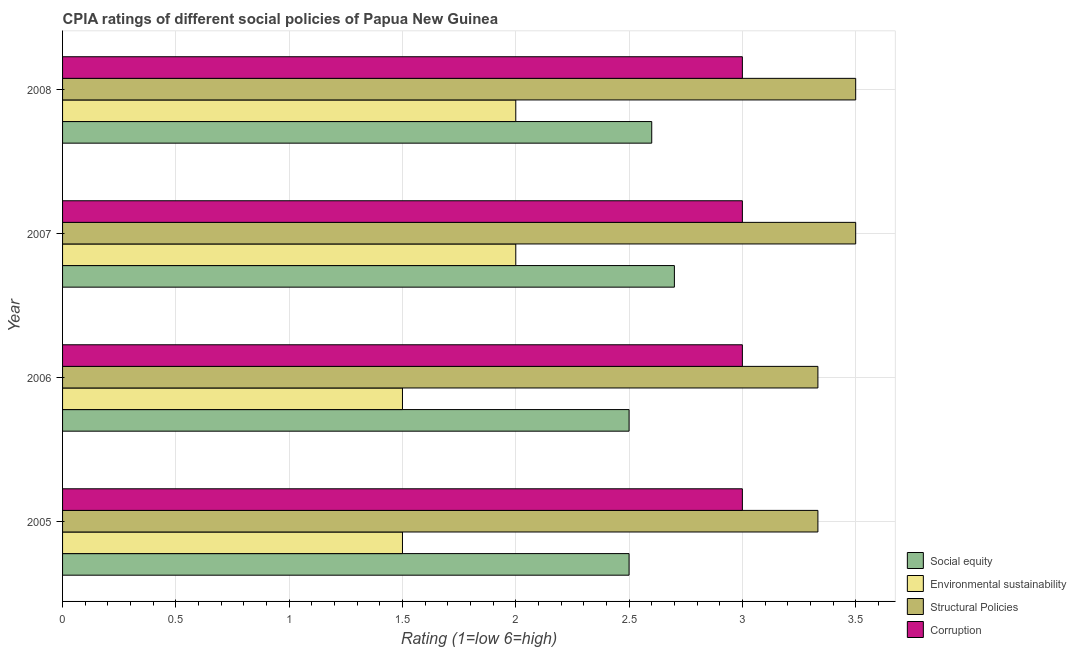How many groups of bars are there?
Provide a succinct answer. 4. Are the number of bars on each tick of the Y-axis equal?
Make the answer very short. Yes. How many bars are there on the 3rd tick from the top?
Give a very brief answer. 4. How many bars are there on the 4th tick from the bottom?
Your answer should be compact. 4. In how many cases, is the number of bars for a given year not equal to the number of legend labels?
Offer a very short reply. 0. What is the cpia rating of corruption in 2007?
Provide a short and direct response. 3. Across all years, what is the minimum cpia rating of environmental sustainability?
Your response must be concise. 1.5. In which year was the cpia rating of social equity maximum?
Your answer should be compact. 2007. In which year was the cpia rating of environmental sustainability minimum?
Offer a very short reply. 2005. What is the total cpia rating of corruption in the graph?
Your answer should be compact. 12. What is the difference between the cpia rating of environmental sustainability in 2007 and the cpia rating of structural policies in 2008?
Provide a short and direct response. -1.5. In the year 2006, what is the difference between the cpia rating of structural policies and cpia rating of corruption?
Provide a short and direct response. 0.33. In how many years, is the cpia rating of environmental sustainability greater than 2.7 ?
Make the answer very short. 0. What is the difference between the highest and the second highest cpia rating of environmental sustainability?
Provide a succinct answer. 0. What is the difference between the highest and the lowest cpia rating of environmental sustainability?
Ensure brevity in your answer.  0.5. In how many years, is the cpia rating of corruption greater than the average cpia rating of corruption taken over all years?
Provide a short and direct response. 0. What does the 1st bar from the top in 2008 represents?
Your response must be concise. Corruption. What does the 3rd bar from the bottom in 2005 represents?
Your answer should be compact. Structural Policies. How many bars are there?
Keep it short and to the point. 16. Are all the bars in the graph horizontal?
Provide a short and direct response. Yes. Are the values on the major ticks of X-axis written in scientific E-notation?
Offer a very short reply. No. Does the graph contain any zero values?
Make the answer very short. No. Does the graph contain grids?
Keep it short and to the point. Yes. Where does the legend appear in the graph?
Ensure brevity in your answer.  Bottom right. How many legend labels are there?
Give a very brief answer. 4. What is the title of the graph?
Provide a short and direct response. CPIA ratings of different social policies of Papua New Guinea. What is the label or title of the X-axis?
Your answer should be compact. Rating (1=low 6=high). What is the Rating (1=low 6=high) in Environmental sustainability in 2005?
Keep it short and to the point. 1.5. What is the Rating (1=low 6=high) of Structural Policies in 2005?
Make the answer very short. 3.33. What is the Rating (1=low 6=high) of Corruption in 2005?
Give a very brief answer. 3. What is the Rating (1=low 6=high) of Social equity in 2006?
Your response must be concise. 2.5. What is the Rating (1=low 6=high) of Structural Policies in 2006?
Provide a succinct answer. 3.33. What is the Rating (1=low 6=high) in Corruption in 2006?
Keep it short and to the point. 3. What is the Rating (1=low 6=high) in Social equity in 2007?
Give a very brief answer. 2.7. What is the Rating (1=low 6=high) of Structural Policies in 2007?
Provide a short and direct response. 3.5. What is the Rating (1=low 6=high) in Corruption in 2007?
Provide a short and direct response. 3. What is the Rating (1=low 6=high) in Structural Policies in 2008?
Ensure brevity in your answer.  3.5. Across all years, what is the maximum Rating (1=low 6=high) of Structural Policies?
Provide a succinct answer. 3.5. Across all years, what is the minimum Rating (1=low 6=high) of Environmental sustainability?
Ensure brevity in your answer.  1.5. Across all years, what is the minimum Rating (1=low 6=high) of Structural Policies?
Your response must be concise. 3.33. What is the total Rating (1=low 6=high) in Social equity in the graph?
Your answer should be compact. 10.3. What is the total Rating (1=low 6=high) of Structural Policies in the graph?
Make the answer very short. 13.67. What is the total Rating (1=low 6=high) in Corruption in the graph?
Ensure brevity in your answer.  12. What is the difference between the Rating (1=low 6=high) of Environmental sustainability in 2005 and that in 2006?
Provide a short and direct response. 0. What is the difference between the Rating (1=low 6=high) in Corruption in 2005 and that in 2006?
Keep it short and to the point. 0. What is the difference between the Rating (1=low 6=high) in Social equity in 2005 and that in 2007?
Your response must be concise. -0.2. What is the difference between the Rating (1=low 6=high) in Corruption in 2005 and that in 2007?
Make the answer very short. 0. What is the difference between the Rating (1=low 6=high) of Social equity in 2005 and that in 2008?
Offer a terse response. -0.1. What is the difference between the Rating (1=low 6=high) of Environmental sustainability in 2005 and that in 2008?
Your answer should be compact. -0.5. What is the difference between the Rating (1=low 6=high) of Structural Policies in 2005 and that in 2008?
Give a very brief answer. -0.17. What is the difference between the Rating (1=low 6=high) of Corruption in 2005 and that in 2008?
Offer a terse response. 0. What is the difference between the Rating (1=low 6=high) of Social equity in 2006 and that in 2007?
Give a very brief answer. -0.2. What is the difference between the Rating (1=low 6=high) of Environmental sustainability in 2006 and that in 2007?
Offer a terse response. -0.5. What is the difference between the Rating (1=low 6=high) in Structural Policies in 2006 and that in 2007?
Offer a terse response. -0.17. What is the difference between the Rating (1=low 6=high) in Corruption in 2006 and that in 2007?
Provide a short and direct response. 0. What is the difference between the Rating (1=low 6=high) of Social equity in 2006 and that in 2008?
Provide a short and direct response. -0.1. What is the difference between the Rating (1=low 6=high) of Structural Policies in 2006 and that in 2008?
Offer a terse response. -0.17. What is the difference between the Rating (1=low 6=high) of Corruption in 2006 and that in 2008?
Ensure brevity in your answer.  0. What is the difference between the Rating (1=low 6=high) of Social equity in 2007 and that in 2008?
Offer a terse response. 0.1. What is the difference between the Rating (1=low 6=high) of Structural Policies in 2007 and that in 2008?
Keep it short and to the point. 0. What is the difference between the Rating (1=low 6=high) in Corruption in 2007 and that in 2008?
Keep it short and to the point. 0. What is the difference between the Rating (1=low 6=high) in Social equity in 2005 and the Rating (1=low 6=high) in Environmental sustainability in 2006?
Provide a short and direct response. 1. What is the difference between the Rating (1=low 6=high) in Social equity in 2005 and the Rating (1=low 6=high) in Corruption in 2006?
Offer a terse response. -0.5. What is the difference between the Rating (1=low 6=high) of Environmental sustainability in 2005 and the Rating (1=low 6=high) of Structural Policies in 2006?
Ensure brevity in your answer.  -1.83. What is the difference between the Rating (1=low 6=high) of Social equity in 2005 and the Rating (1=low 6=high) of Corruption in 2007?
Offer a very short reply. -0.5. What is the difference between the Rating (1=low 6=high) in Environmental sustainability in 2005 and the Rating (1=low 6=high) in Corruption in 2007?
Ensure brevity in your answer.  -1.5. What is the difference between the Rating (1=low 6=high) in Social equity in 2005 and the Rating (1=low 6=high) in Environmental sustainability in 2008?
Provide a succinct answer. 0.5. What is the difference between the Rating (1=low 6=high) in Social equity in 2005 and the Rating (1=low 6=high) in Corruption in 2008?
Provide a succinct answer. -0.5. What is the difference between the Rating (1=low 6=high) in Structural Policies in 2005 and the Rating (1=low 6=high) in Corruption in 2008?
Offer a terse response. 0.33. What is the difference between the Rating (1=low 6=high) of Social equity in 2006 and the Rating (1=low 6=high) of Environmental sustainability in 2007?
Your answer should be compact. 0.5. What is the difference between the Rating (1=low 6=high) of Social equity in 2006 and the Rating (1=low 6=high) of Corruption in 2007?
Give a very brief answer. -0.5. What is the difference between the Rating (1=low 6=high) of Environmental sustainability in 2006 and the Rating (1=low 6=high) of Corruption in 2007?
Your response must be concise. -1.5. What is the difference between the Rating (1=low 6=high) in Social equity in 2006 and the Rating (1=low 6=high) in Environmental sustainability in 2008?
Ensure brevity in your answer.  0.5. What is the difference between the Rating (1=low 6=high) of Environmental sustainability in 2006 and the Rating (1=low 6=high) of Corruption in 2008?
Your response must be concise. -1.5. What is the difference between the Rating (1=low 6=high) of Social equity in 2007 and the Rating (1=low 6=high) of Environmental sustainability in 2008?
Give a very brief answer. 0.7. What is the difference between the Rating (1=low 6=high) in Environmental sustainability in 2007 and the Rating (1=low 6=high) in Corruption in 2008?
Keep it short and to the point. -1. What is the difference between the Rating (1=low 6=high) in Structural Policies in 2007 and the Rating (1=low 6=high) in Corruption in 2008?
Your answer should be compact. 0.5. What is the average Rating (1=low 6=high) of Social equity per year?
Ensure brevity in your answer.  2.58. What is the average Rating (1=low 6=high) of Environmental sustainability per year?
Your response must be concise. 1.75. What is the average Rating (1=low 6=high) in Structural Policies per year?
Your response must be concise. 3.42. In the year 2005, what is the difference between the Rating (1=low 6=high) of Social equity and Rating (1=low 6=high) of Structural Policies?
Provide a succinct answer. -0.83. In the year 2005, what is the difference between the Rating (1=low 6=high) of Environmental sustainability and Rating (1=low 6=high) of Structural Policies?
Keep it short and to the point. -1.83. In the year 2005, what is the difference between the Rating (1=low 6=high) in Environmental sustainability and Rating (1=low 6=high) in Corruption?
Offer a terse response. -1.5. In the year 2005, what is the difference between the Rating (1=low 6=high) of Structural Policies and Rating (1=low 6=high) of Corruption?
Give a very brief answer. 0.33. In the year 2006, what is the difference between the Rating (1=low 6=high) in Social equity and Rating (1=low 6=high) in Structural Policies?
Give a very brief answer. -0.83. In the year 2006, what is the difference between the Rating (1=low 6=high) in Environmental sustainability and Rating (1=low 6=high) in Structural Policies?
Your answer should be compact. -1.83. In the year 2006, what is the difference between the Rating (1=low 6=high) of Structural Policies and Rating (1=low 6=high) of Corruption?
Ensure brevity in your answer.  0.33. In the year 2007, what is the difference between the Rating (1=low 6=high) in Social equity and Rating (1=low 6=high) in Environmental sustainability?
Your response must be concise. 0.7. In the year 2007, what is the difference between the Rating (1=low 6=high) of Social equity and Rating (1=low 6=high) of Structural Policies?
Ensure brevity in your answer.  -0.8. In the year 2007, what is the difference between the Rating (1=low 6=high) in Social equity and Rating (1=low 6=high) in Corruption?
Keep it short and to the point. -0.3. In the year 2007, what is the difference between the Rating (1=low 6=high) in Environmental sustainability and Rating (1=low 6=high) in Structural Policies?
Provide a short and direct response. -1.5. In the year 2008, what is the difference between the Rating (1=low 6=high) of Social equity and Rating (1=low 6=high) of Structural Policies?
Your answer should be compact. -0.9. In the year 2008, what is the difference between the Rating (1=low 6=high) in Social equity and Rating (1=low 6=high) in Corruption?
Make the answer very short. -0.4. What is the ratio of the Rating (1=low 6=high) of Social equity in 2005 to that in 2006?
Offer a very short reply. 1. What is the ratio of the Rating (1=low 6=high) in Environmental sustainability in 2005 to that in 2006?
Ensure brevity in your answer.  1. What is the ratio of the Rating (1=low 6=high) of Corruption in 2005 to that in 2006?
Provide a short and direct response. 1. What is the ratio of the Rating (1=low 6=high) of Social equity in 2005 to that in 2007?
Keep it short and to the point. 0.93. What is the ratio of the Rating (1=low 6=high) in Environmental sustainability in 2005 to that in 2007?
Offer a very short reply. 0.75. What is the ratio of the Rating (1=low 6=high) in Structural Policies in 2005 to that in 2007?
Provide a succinct answer. 0.95. What is the ratio of the Rating (1=low 6=high) in Corruption in 2005 to that in 2007?
Provide a succinct answer. 1. What is the ratio of the Rating (1=low 6=high) in Social equity in 2005 to that in 2008?
Provide a succinct answer. 0.96. What is the ratio of the Rating (1=low 6=high) in Environmental sustainability in 2005 to that in 2008?
Make the answer very short. 0.75. What is the ratio of the Rating (1=low 6=high) of Social equity in 2006 to that in 2007?
Provide a short and direct response. 0.93. What is the ratio of the Rating (1=low 6=high) in Environmental sustainability in 2006 to that in 2007?
Your response must be concise. 0.75. What is the ratio of the Rating (1=low 6=high) in Structural Policies in 2006 to that in 2007?
Ensure brevity in your answer.  0.95. What is the ratio of the Rating (1=low 6=high) of Corruption in 2006 to that in 2007?
Give a very brief answer. 1. What is the ratio of the Rating (1=low 6=high) in Social equity in 2006 to that in 2008?
Your answer should be compact. 0.96. What is the ratio of the Rating (1=low 6=high) in Structural Policies in 2006 to that in 2008?
Keep it short and to the point. 0.95. What is the ratio of the Rating (1=low 6=high) in Corruption in 2006 to that in 2008?
Offer a very short reply. 1. What is the ratio of the Rating (1=low 6=high) in Environmental sustainability in 2007 to that in 2008?
Keep it short and to the point. 1. What is the ratio of the Rating (1=low 6=high) in Structural Policies in 2007 to that in 2008?
Offer a very short reply. 1. What is the ratio of the Rating (1=low 6=high) in Corruption in 2007 to that in 2008?
Give a very brief answer. 1. What is the difference between the highest and the second highest Rating (1=low 6=high) in Social equity?
Provide a short and direct response. 0.1. What is the difference between the highest and the lowest Rating (1=low 6=high) in Social equity?
Ensure brevity in your answer.  0.2. 